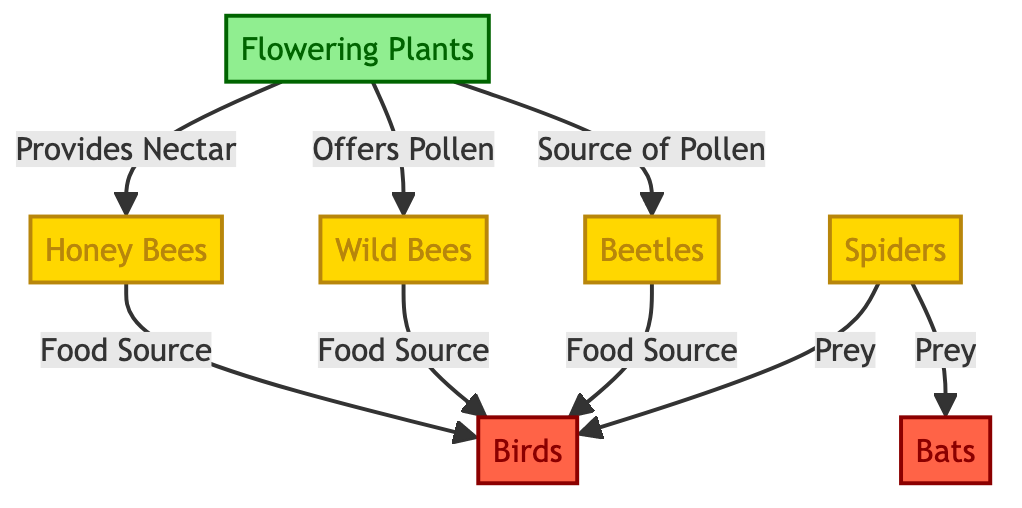What's the total number of different insects in the diagram? The diagram shows three different insects: honey bees, wild bees, and beetles. By counting these nodes, we find there are three insects represented.
Answer: 3 What food sources do honey bees provide? According to the diagram, honey bees are linked to birds as a food source. Therefore, honey bees provide food specifically for birds.
Answer: Birds How many types of predators are represented in the diagram? The diagram includes two types of predators: birds and bats. By identifying the nodes representing predators, we find there are two types.
Answer: 2 Which flowering plants offer pollen to wild bees? The diagram shows that flowering plants provide annual sources of pollen for wild bees through a direct link. So, flowering plants offer pollen.
Answer: Flowering plants How many food sources do spiders provide? The diagram indicates that spiders serve as prey for both birds and bats. Therefore, by analyzing the links from the spiders, we can see they provide food for two distinct predators.
Answer: 2 